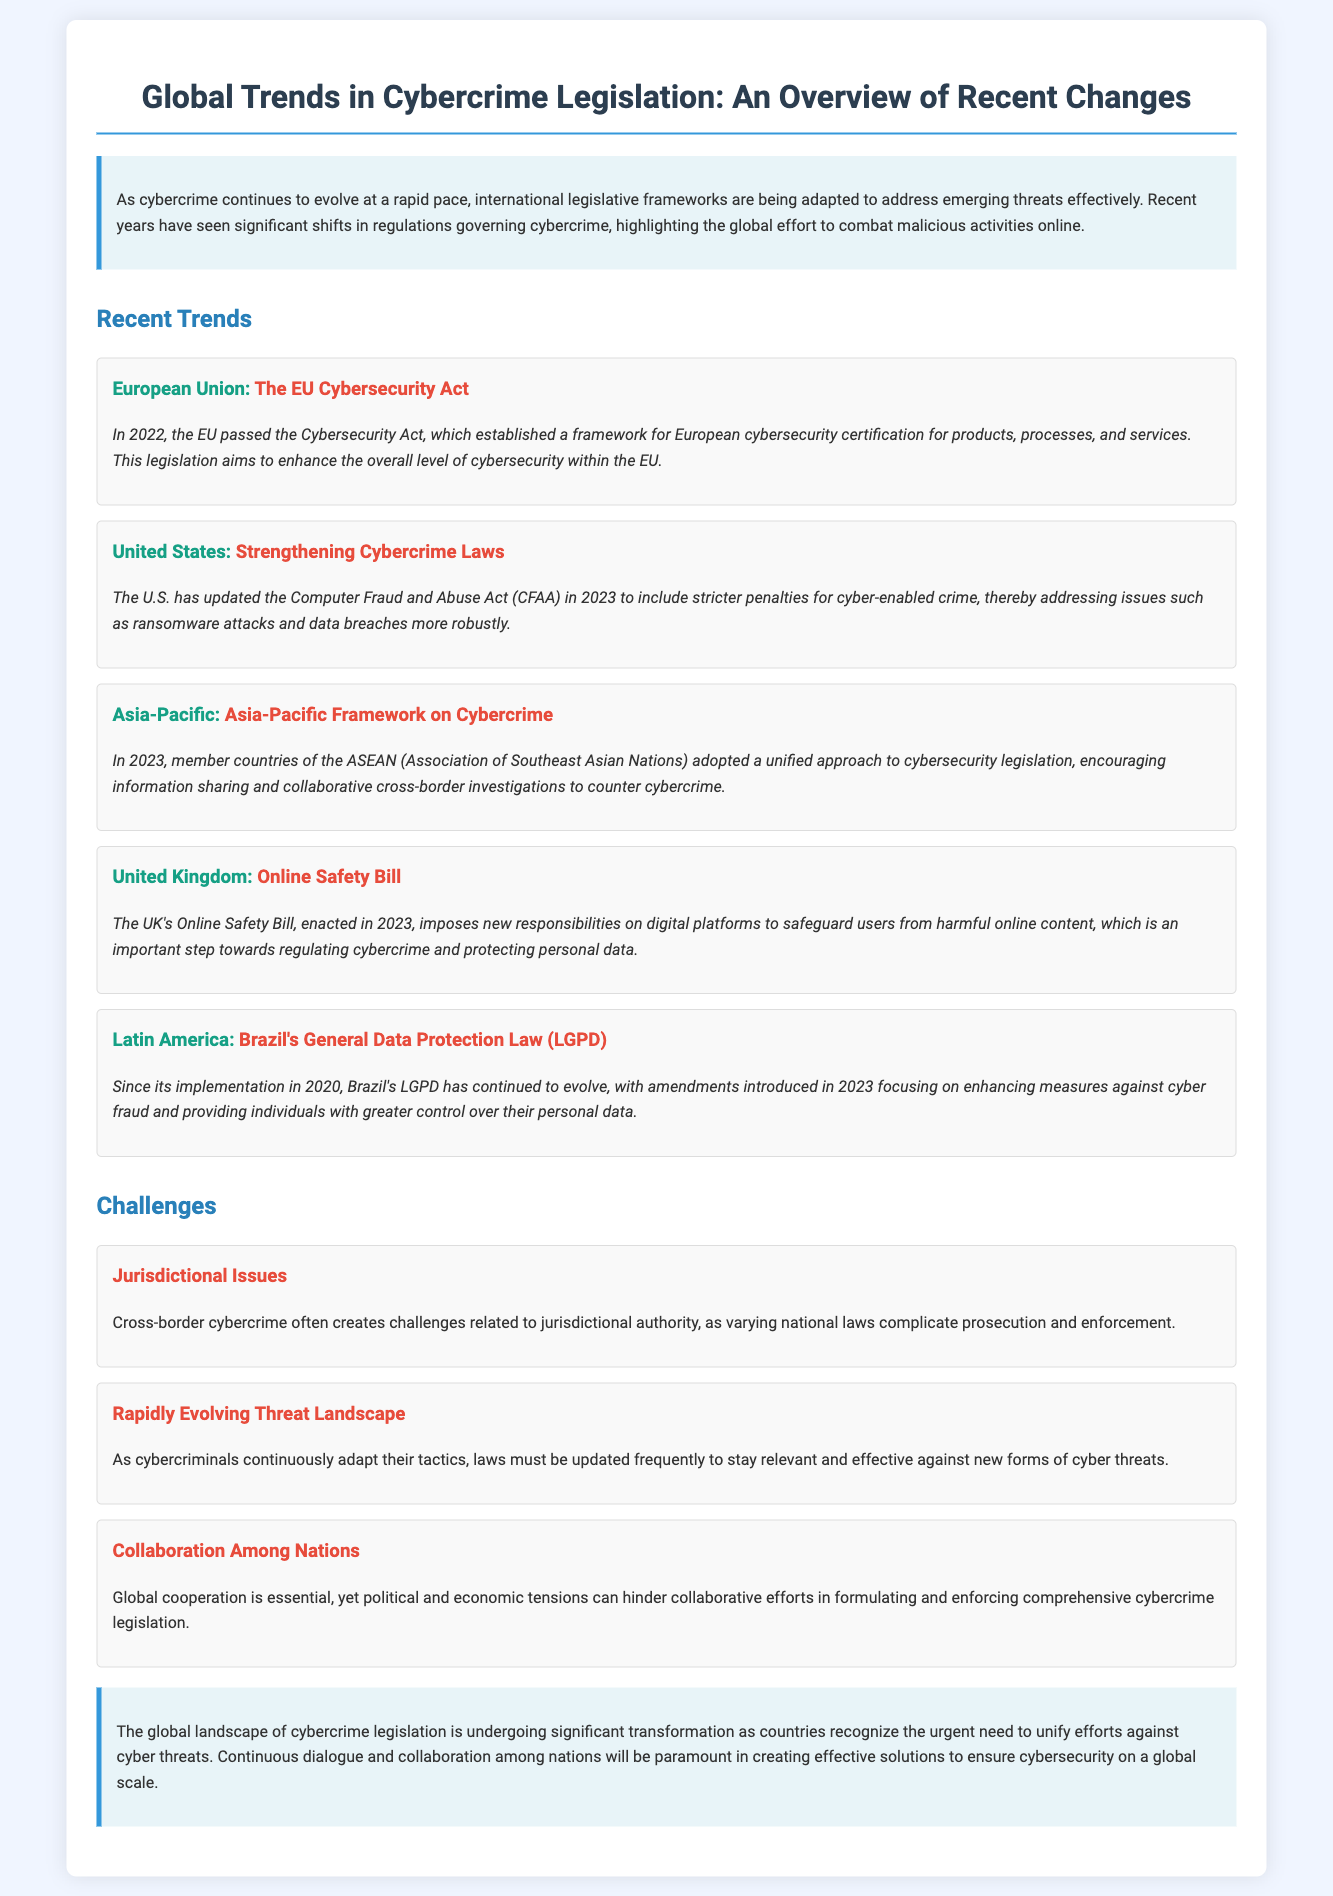What is the title of the document? The title of the document is stated at the top, indicating the subject matter it addresses.
Answer: Global Trends in Cybercrime Legislation: An Overview of Recent Changes In what year was the EU Cybersecurity Act passed? The document specifies the year of the EU Cybersecurity Act's passage within the section on recent trends.
Answer: 2022 What is the main focus of the UK's Online Safety Bill? The document mentions the key responsibilities imposed by the UK's Online Safety Bill related to digital platforms and online content.
Answer: Safeguard users from harmful online content Which country's General Data Protection Law has been amended to focus on cyber fraud measures? The document identifies Brazil's law and its amendments regarding cyber fraud, located in the Latin America trend section.
Answer: Brazil's General Data Protection Law (LGPD) What is a significant challenge mentioned related to cross-border cybercrime? The document outlines challenges related to jurisdictional authority when dealing with cybercrime that crosses national boundaries.
Answer: Jurisdictional Issues What year did the U.S. update the Computer Fraud and Abuse Act? The specific year of the U.S. law's update is provided in the relevant trend about strengthening cybercrime laws.
Answer: 2023 What framework was adopted by ASEAN member countries in 2023? The document details the Asia-Pacific framework adopted for addressing cybersecurity collaboratively.
Answer: Asia-Pacific Framework on Cybercrime What is the overall trend in global cybercrime legislation as mentioned in the conclusion? The conclusion summarizes the evolving nature of international legislation in response to cyber threats globally.
Answer: Significant transformation 